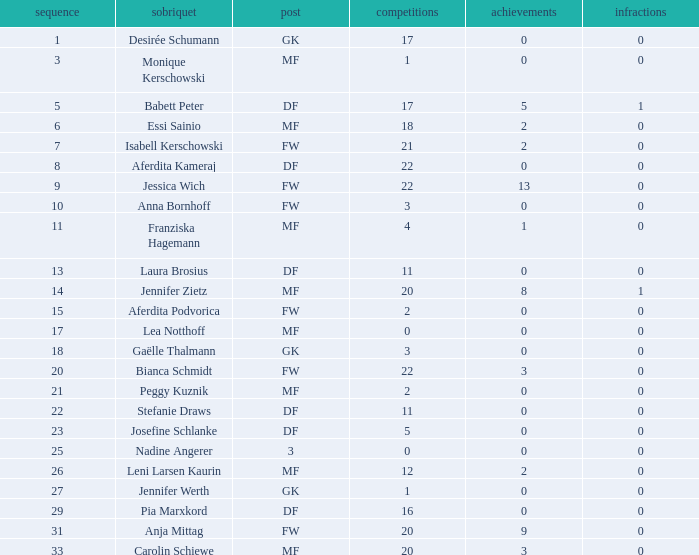What is the average goals for Essi Sainio? 2.0. 